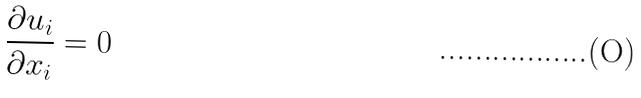<formula> <loc_0><loc_0><loc_500><loc_500>\frac { \partial u _ { i } } { \partial x _ { i } } = 0</formula> 